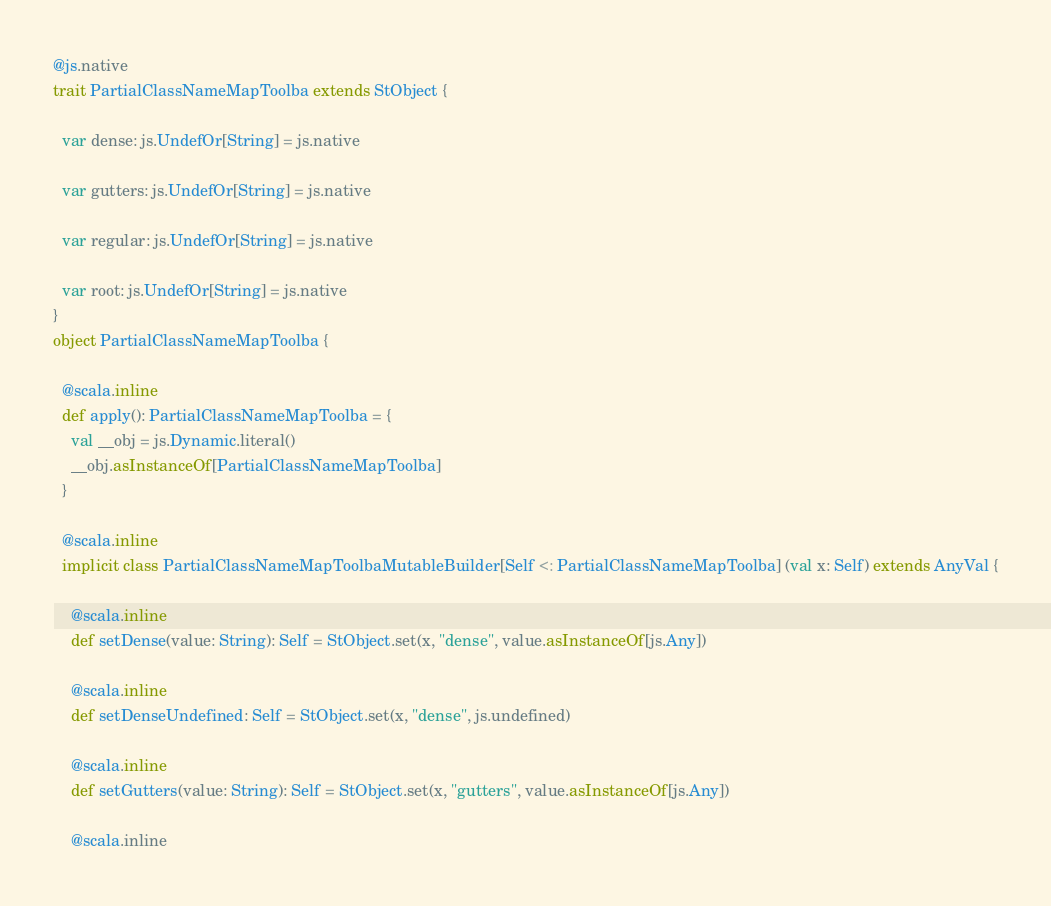<code> <loc_0><loc_0><loc_500><loc_500><_Scala_>@js.native
trait PartialClassNameMapToolba extends StObject {
  
  var dense: js.UndefOr[String] = js.native
  
  var gutters: js.UndefOr[String] = js.native
  
  var regular: js.UndefOr[String] = js.native
  
  var root: js.UndefOr[String] = js.native
}
object PartialClassNameMapToolba {
  
  @scala.inline
  def apply(): PartialClassNameMapToolba = {
    val __obj = js.Dynamic.literal()
    __obj.asInstanceOf[PartialClassNameMapToolba]
  }
  
  @scala.inline
  implicit class PartialClassNameMapToolbaMutableBuilder[Self <: PartialClassNameMapToolba] (val x: Self) extends AnyVal {
    
    @scala.inline
    def setDense(value: String): Self = StObject.set(x, "dense", value.asInstanceOf[js.Any])
    
    @scala.inline
    def setDenseUndefined: Self = StObject.set(x, "dense", js.undefined)
    
    @scala.inline
    def setGutters(value: String): Self = StObject.set(x, "gutters", value.asInstanceOf[js.Any])
    
    @scala.inline</code> 